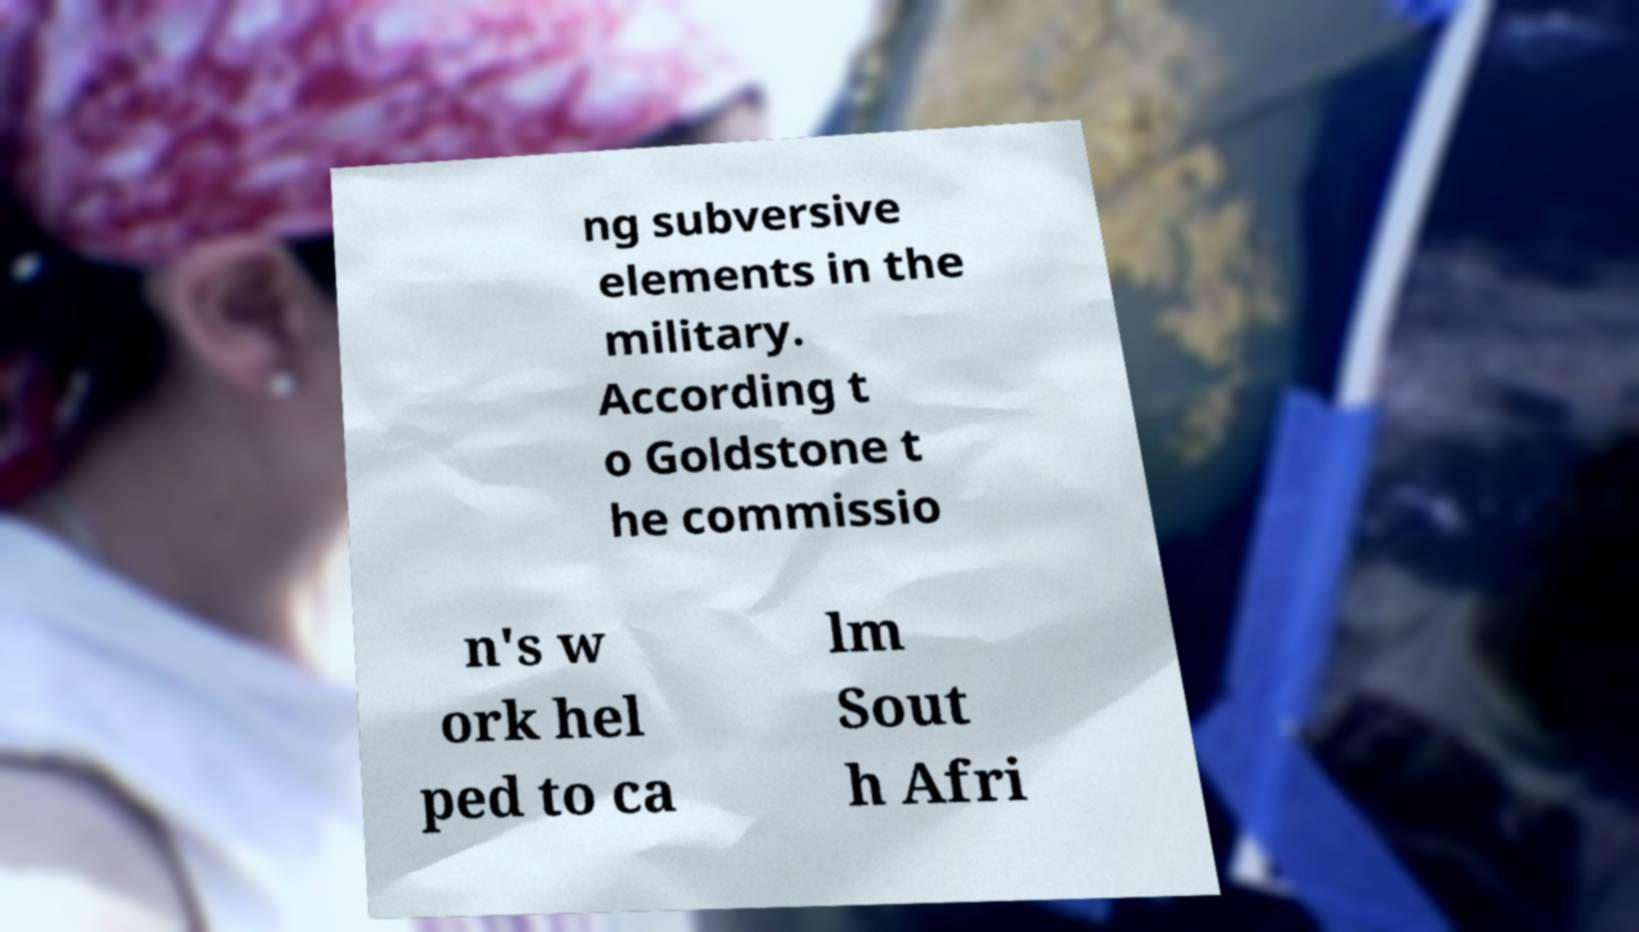What messages or text are displayed in this image? I need them in a readable, typed format. ng subversive elements in the military. According t o Goldstone t he commissio n's w ork hel ped to ca lm Sout h Afri 